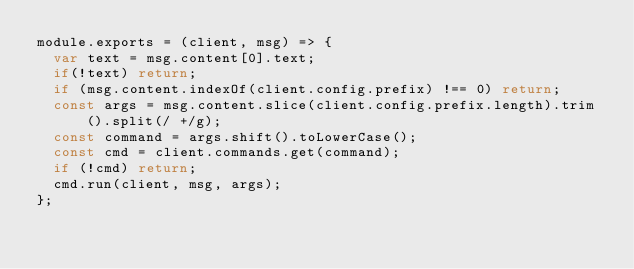<code> <loc_0><loc_0><loc_500><loc_500><_JavaScript_>module.exports = (client, msg) => {
  var text = msg.content[0].text;
  if(!text) return;
  if (msg.content.indexOf(client.config.prefix) !== 0) return;
  const args = msg.content.slice(client.config.prefix.length).trim().split(/ +/g);
  const command = args.shift().toLowerCase();
  const cmd = client.commands.get(command);
  if (!cmd) return;
  cmd.run(client, msg, args);
};
</code> 